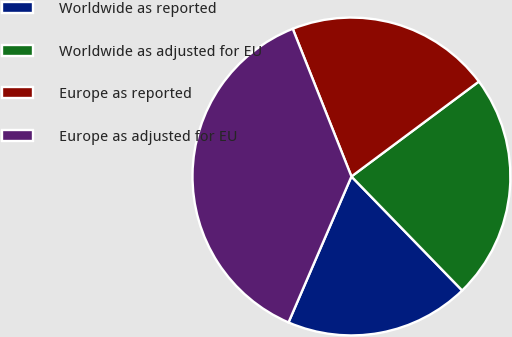<chart> <loc_0><loc_0><loc_500><loc_500><pie_chart><fcel>Worldwide as reported<fcel>Worldwide as adjusted for EU<fcel>Europe as reported<fcel>Europe as adjusted for EU<nl><fcel>18.75%<fcel>22.92%<fcel>20.83%<fcel>37.5%<nl></chart> 